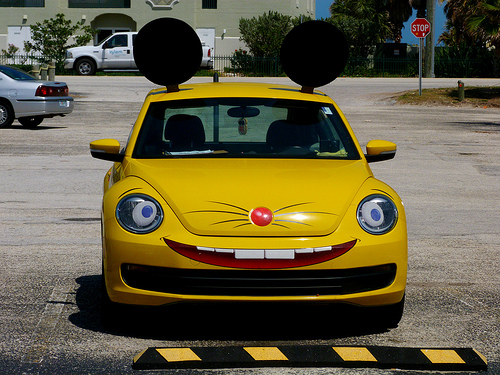<image>
Can you confirm if the car is on the land? Yes. Looking at the image, I can see the car is positioned on top of the land, with the land providing support. 